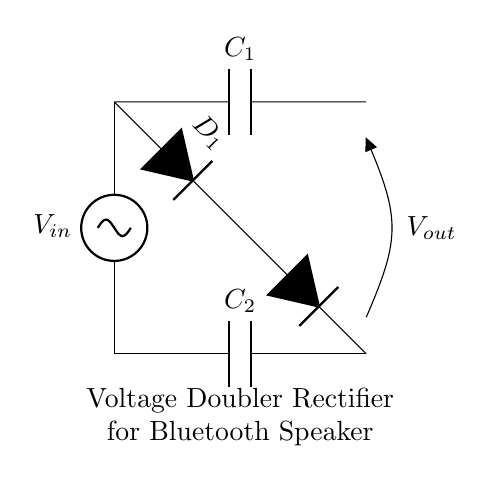What is the input voltage in this circuit? The circuit diagram shows the ac voltage source labeled as Vin, but does not specify a numerical value. Therefore, we acknowledge it's an unspecified alternating voltage.
Answer: Vin What components are used in this voltage doubler rectifier? The diagram consists of two capacitors (C1, C2) and two diodes (D1, D2). These components are essential for converting the AC input into a higher DC output voltage.
Answer: C1, C2, D1, D2 What is the role of capacitor C1? Capacitor C1 stores charge when the input voltage is positive, contributing to the voltage doubling effect by maintaining a higher voltage at the output.
Answer: Charge storage How many diodes are present in the circuit? The diagram illustrates two diodes (D1 and D2) that rectify the input voltage to produce the output voltage. The presence of both diodes is crucial for the functioning of the voltage doubler.
Answer: Two What is the output voltage referenced in the circuit? The output voltage Vout is not marked with a specific numerical value in the diagram, but since this is a voltage doubler configuration, the output will be approximately double the input voltage based on ideal conditions.
Answer: 2Vin Why is this circuit designed as a voltage doubler? The voltage doubler design is used to increase the output voltage relative to the input, which is useful for providing a higher energy source needed for powering portable Bluetooth speakers.
Answer: To increase output voltage 